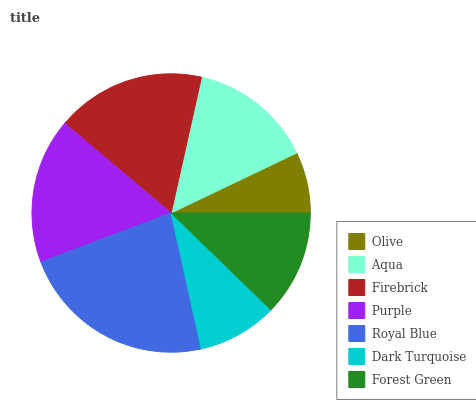Is Olive the minimum?
Answer yes or no. Yes. Is Royal Blue the maximum?
Answer yes or no. Yes. Is Aqua the minimum?
Answer yes or no. No. Is Aqua the maximum?
Answer yes or no. No. Is Aqua greater than Olive?
Answer yes or no. Yes. Is Olive less than Aqua?
Answer yes or no. Yes. Is Olive greater than Aqua?
Answer yes or no. No. Is Aqua less than Olive?
Answer yes or no. No. Is Aqua the high median?
Answer yes or no. Yes. Is Aqua the low median?
Answer yes or no. Yes. Is Forest Green the high median?
Answer yes or no. No. Is Dark Turquoise the low median?
Answer yes or no. No. 